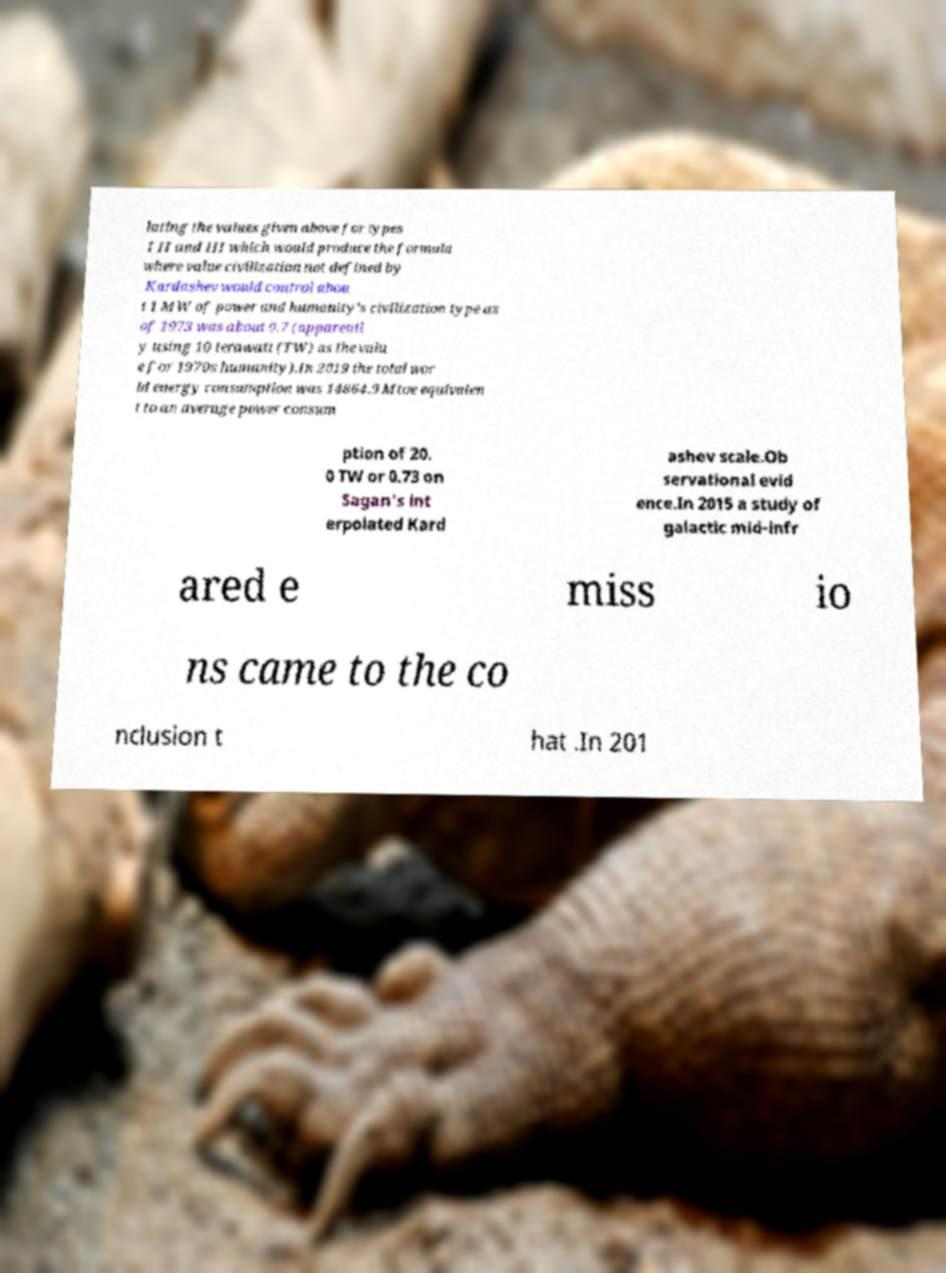Can you accurately transcribe the text from the provided image for me? lating the values given above for types I II and III which would produce the formula where value civilization not defined by Kardashev would control abou t 1 MW of power and humanity's civilization type as of 1973 was about 0.7 (apparentl y using 10 terawatt (TW) as the valu e for 1970s humanity).In 2019 the total wor ld energy consumption was 14864.9 Mtoe equivalen t to an average power consum ption of 20. 0 TW or 0.73 on Sagan's int erpolated Kard ashev scale.Ob servational evid ence.In 2015 a study of galactic mid-infr ared e miss io ns came to the co nclusion t hat .In 201 